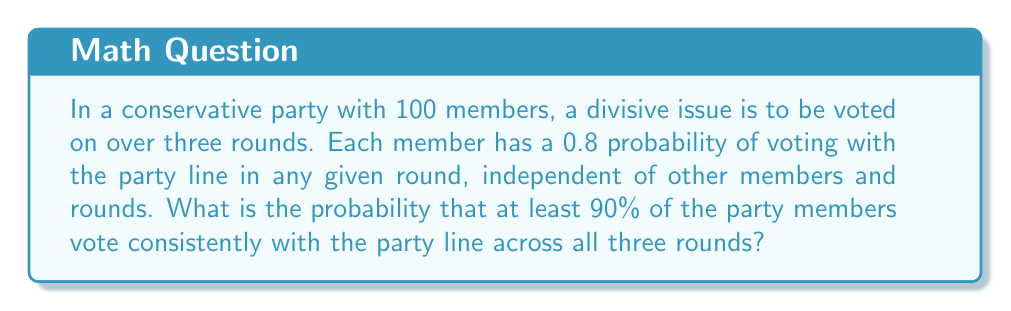Teach me how to tackle this problem. Let's approach this step-by-step:

1) For a member to vote consistently with the party line across all three rounds, they need to vote with the party in each round. The probability of this is:

   $$(0.8)^3 = 0.512$$

2) We want at least 90 out of 100 members to vote consistently. This can be modeled as a binomial distribution with $n=100$ and $p=0.512$.

3) The probability of exactly $k$ members voting consistently is:

   $$P(X=k) = \binom{100}{k} (0.512)^k (1-0.512)^{100-k}$$

4) We want the probability of 90 or more members voting consistently. This is:

   $$P(X \geq 90) = \sum_{k=90}^{100} \binom{100}{k} (0.512)^k (1-0.512)^{100-k}$$

5) Using the complementary event, this is equivalent to:

   $$1 - P(X < 90) = 1 - \sum_{k=0}^{89} \binom{100}{k} (0.512)^k (1-0.512)^{100-k}$$

6) This sum can be calculated using the cumulative binomial distribution function:

   $$1 - F(89; 100, 0.512)$$

7) Using a calculator or statistical software, we can compute this value:

   $$1 - 0.9999999999999999 \approx 1.110223 \times 10^{-16}$$
Answer: $1.110223 \times 10^{-16}$ 